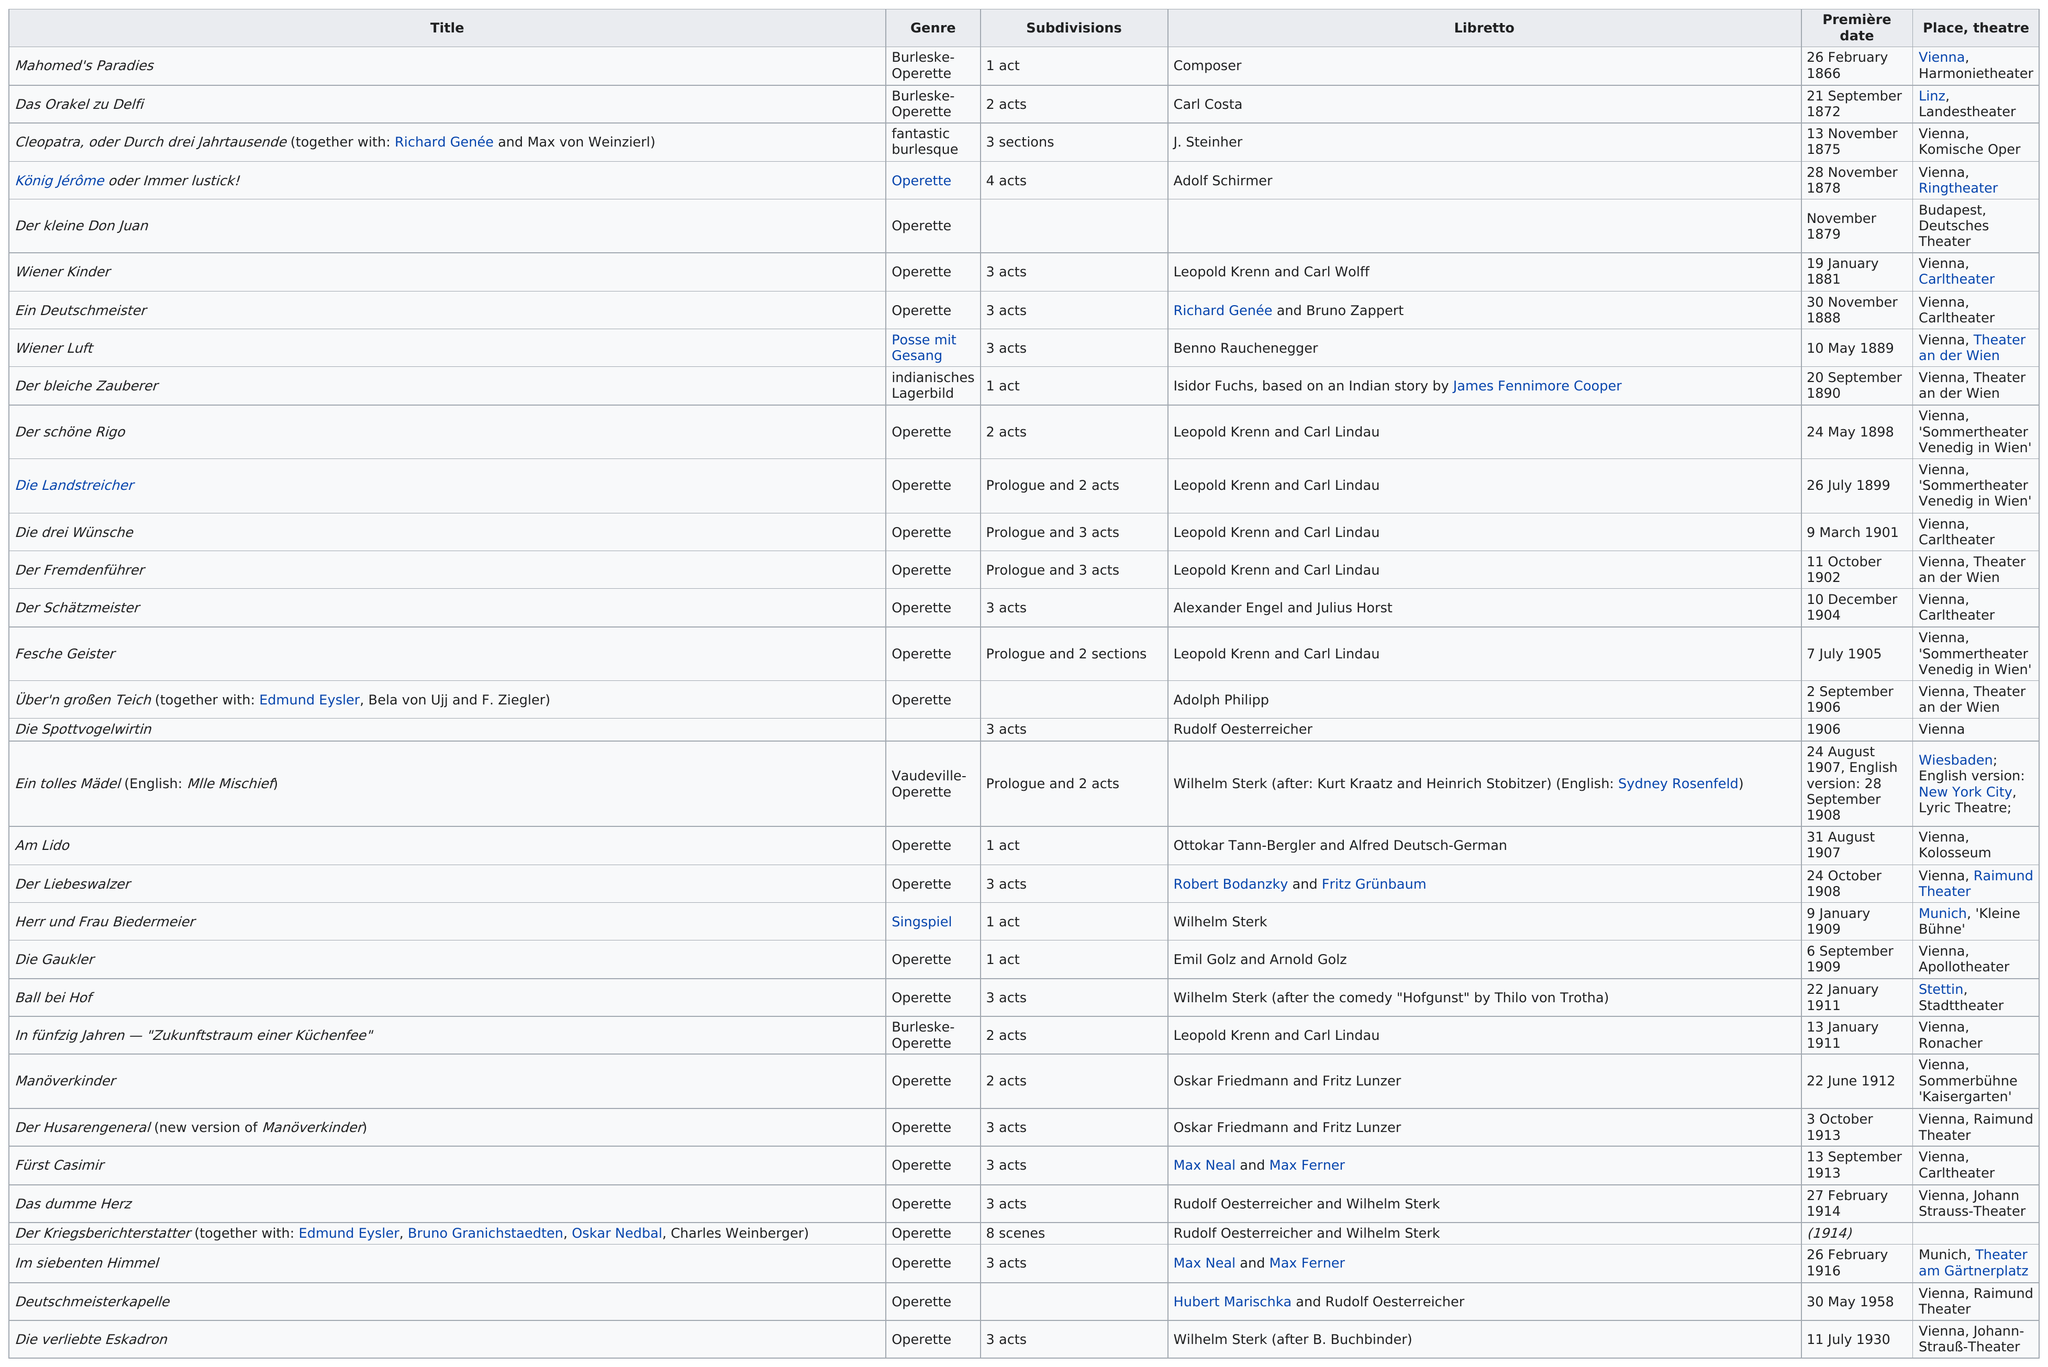Outline some significant characteristics in this image. There were four titles that premiered in the month of September. The Love Walzer and Manöverkinder contain an equal number of acts. In 1958, the last title was awarded. There were 5 acts in total. In the chart, operetta is the genre that is featured the most. 